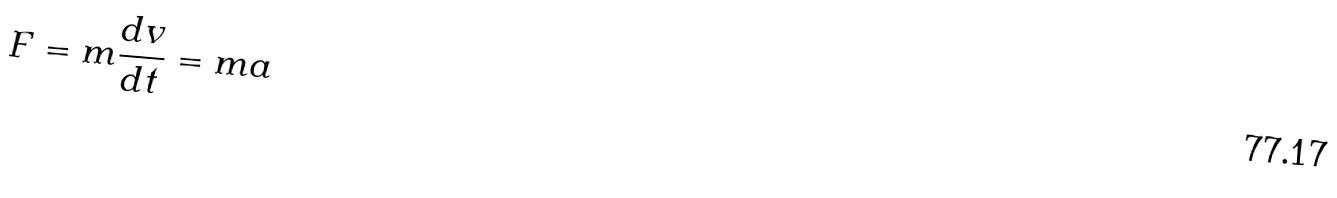Convert formula to latex. <formula><loc_0><loc_0><loc_500><loc_500>F = m \frac { d v } { d t } = m a</formula> 